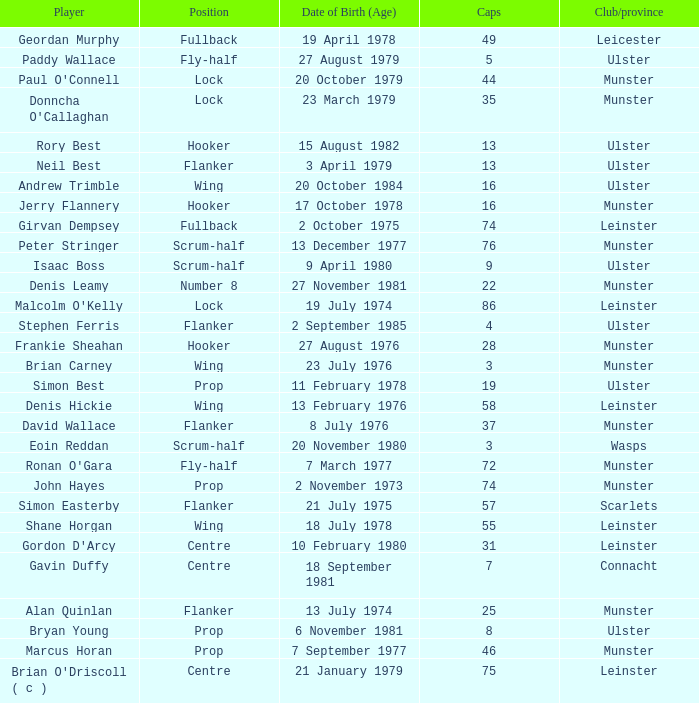What is the club or province of Girvan Dempsey, who has 74 caps? Leinster. 